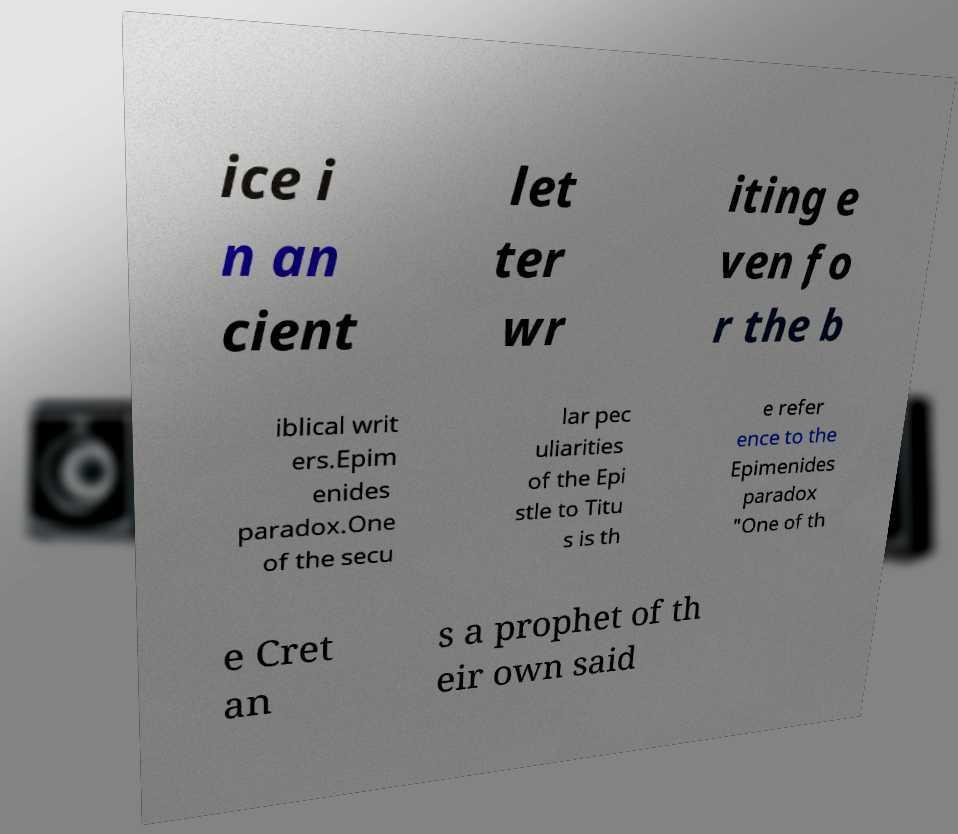Can you read and provide the text displayed in the image?This photo seems to have some interesting text. Can you extract and type it out for me? ice i n an cient let ter wr iting e ven fo r the b iblical writ ers.Epim enides paradox.One of the secu lar pec uliarities of the Epi stle to Titu s is th e refer ence to the Epimenides paradox "One of th e Cret an s a prophet of th eir own said 